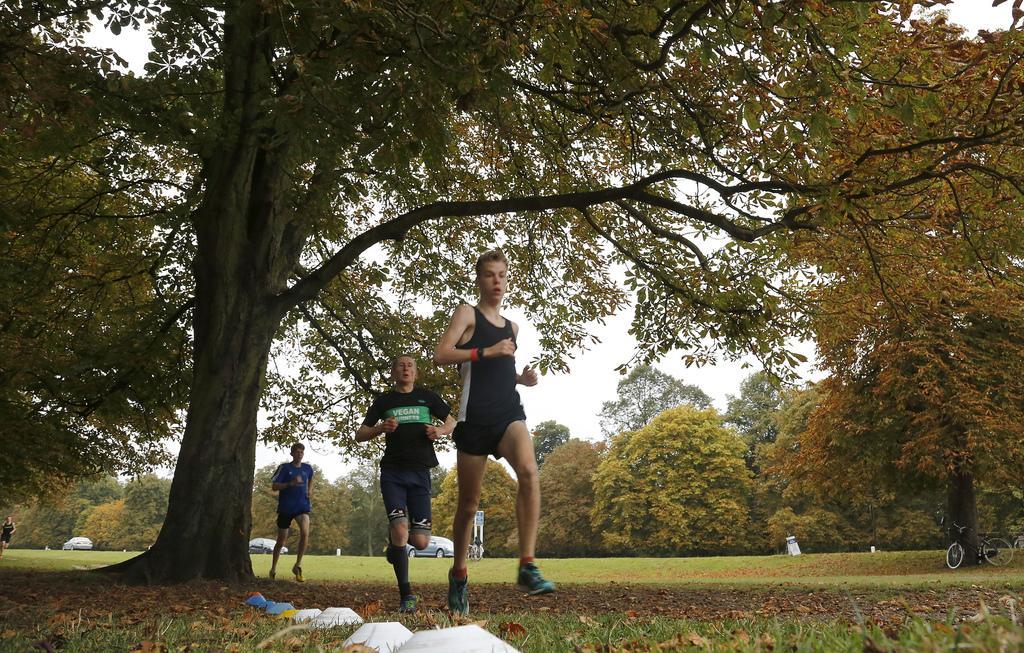Describe this image in one or two sentences. In the center of the image there are people jogging. At the bottom of the image there are some objects placed on the grass. In the background of the image there are trees,cars. To the right side of the image there is a bicycle under the tree. 